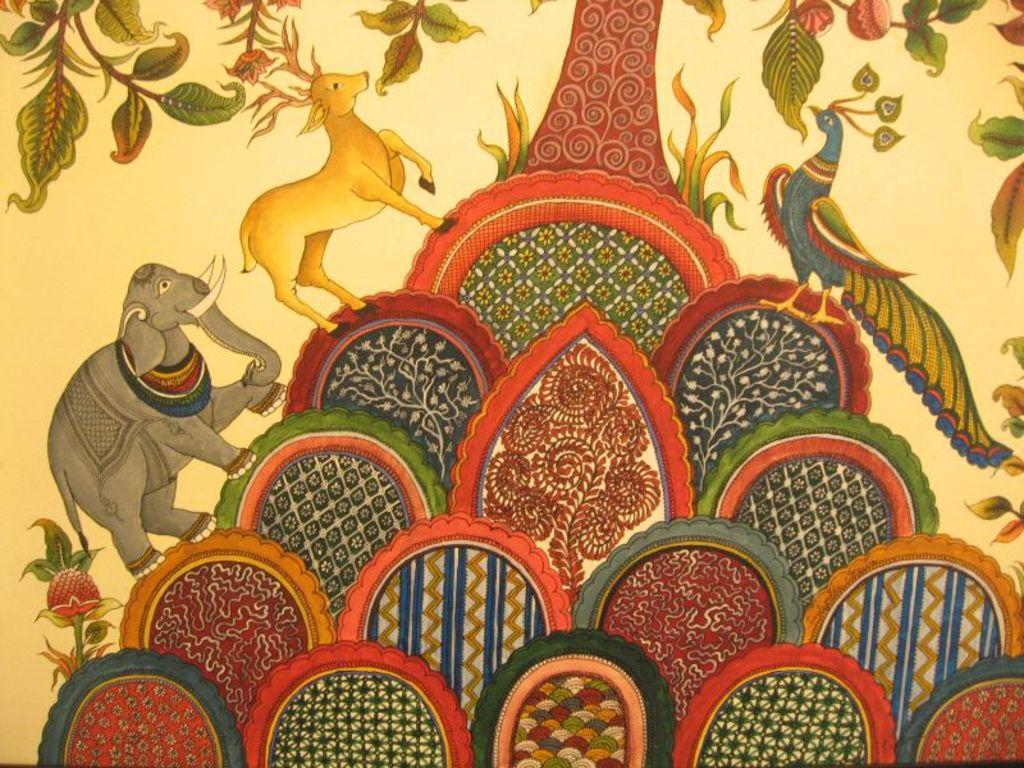What is the main subject of the image? The image contains a painting. What type of animals are depicted in the painting? The painting depicts animals. Can you identify any specific animals in the painting? Yes, the painting includes a peacock. Are there any other elements in the painting besides the animals? Yes, the painting includes a tree. How many clocks are hanging on the tree in the painting? There are no clocks present in the painting; it features animals and a tree. What type of wound does the peacock have in the painting? There is no wound on the peacock in the painting; it appears to be healthy and uninjured. 